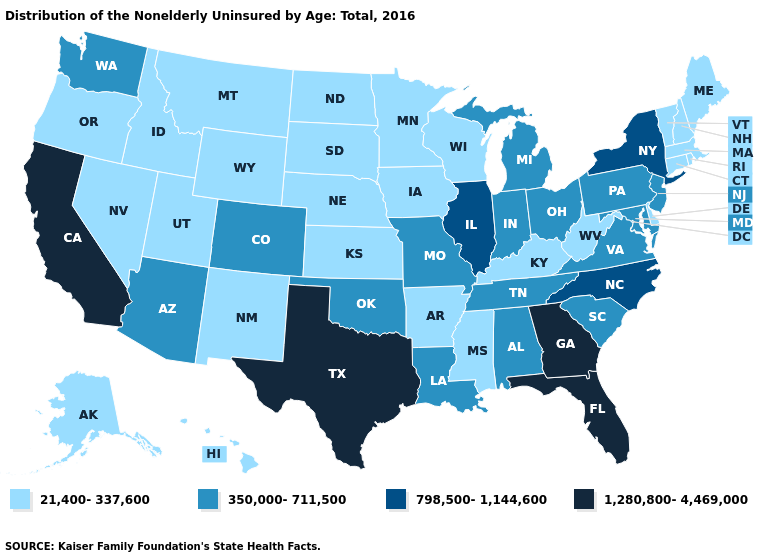What is the lowest value in the USA?
Keep it brief. 21,400-337,600. Name the states that have a value in the range 1,280,800-4,469,000?
Quick response, please. California, Florida, Georgia, Texas. Does Pennsylvania have the lowest value in the Northeast?
Short answer required. No. Name the states that have a value in the range 798,500-1,144,600?
Concise answer only. Illinois, New York, North Carolina. Does the first symbol in the legend represent the smallest category?
Quick response, please. Yes. Which states have the lowest value in the MidWest?
Be succinct. Iowa, Kansas, Minnesota, Nebraska, North Dakota, South Dakota, Wisconsin. Name the states that have a value in the range 1,280,800-4,469,000?
Short answer required. California, Florida, Georgia, Texas. Is the legend a continuous bar?
Give a very brief answer. No. Name the states that have a value in the range 1,280,800-4,469,000?
Quick response, please. California, Florida, Georgia, Texas. What is the lowest value in the South?
Be succinct. 21,400-337,600. What is the value of Kansas?
Concise answer only. 21,400-337,600. What is the value of Texas?
Be succinct. 1,280,800-4,469,000. Does the map have missing data?
Be succinct. No. What is the lowest value in the USA?
Write a very short answer. 21,400-337,600. Does the first symbol in the legend represent the smallest category?
Give a very brief answer. Yes. 